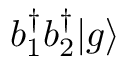Convert formula to latex. <formula><loc_0><loc_0><loc_500><loc_500>b _ { 1 } ^ { \dagger } b _ { 2 } ^ { \dagger } { | g \rangle }</formula> 